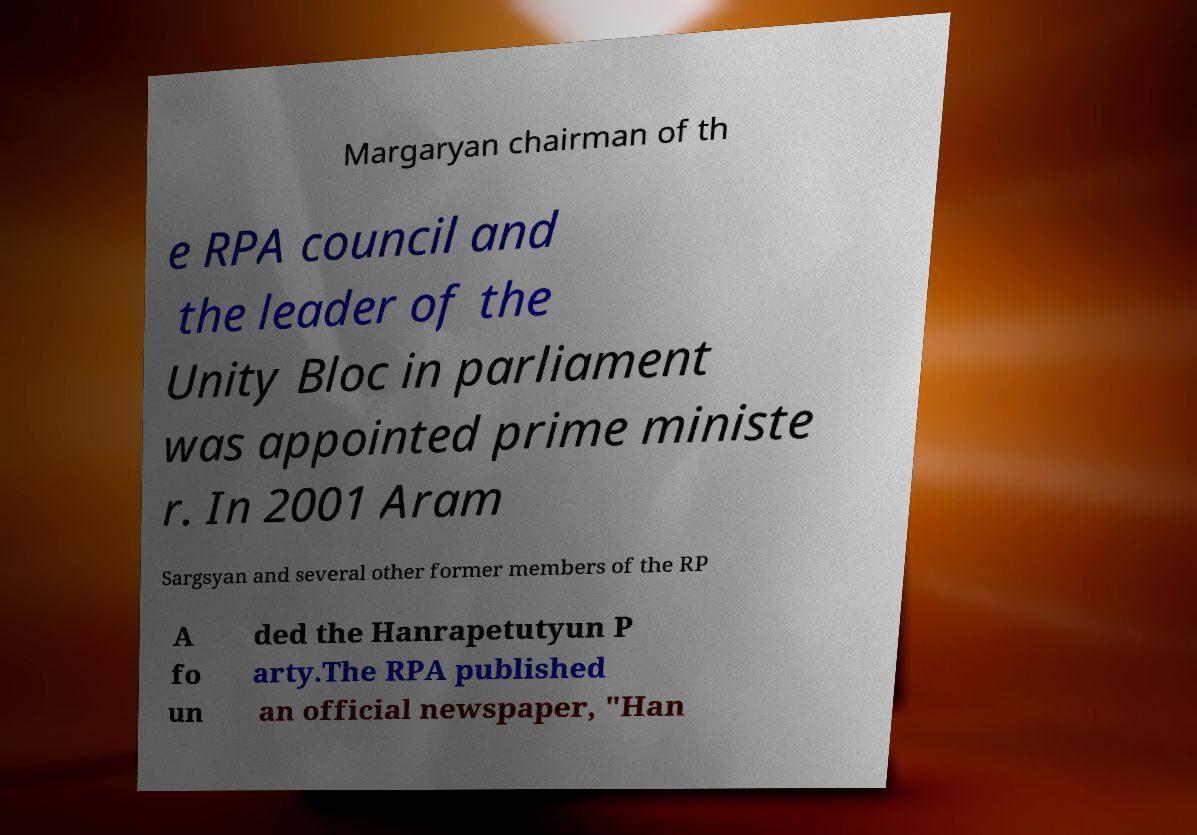Could you extract and type out the text from this image? Margaryan chairman of th e RPA council and the leader of the Unity Bloc in parliament was appointed prime ministe r. In 2001 Aram Sargsyan and several other former members of the RP A fo un ded the Hanrapetutyun P arty.The RPA published an official newspaper, "Han 